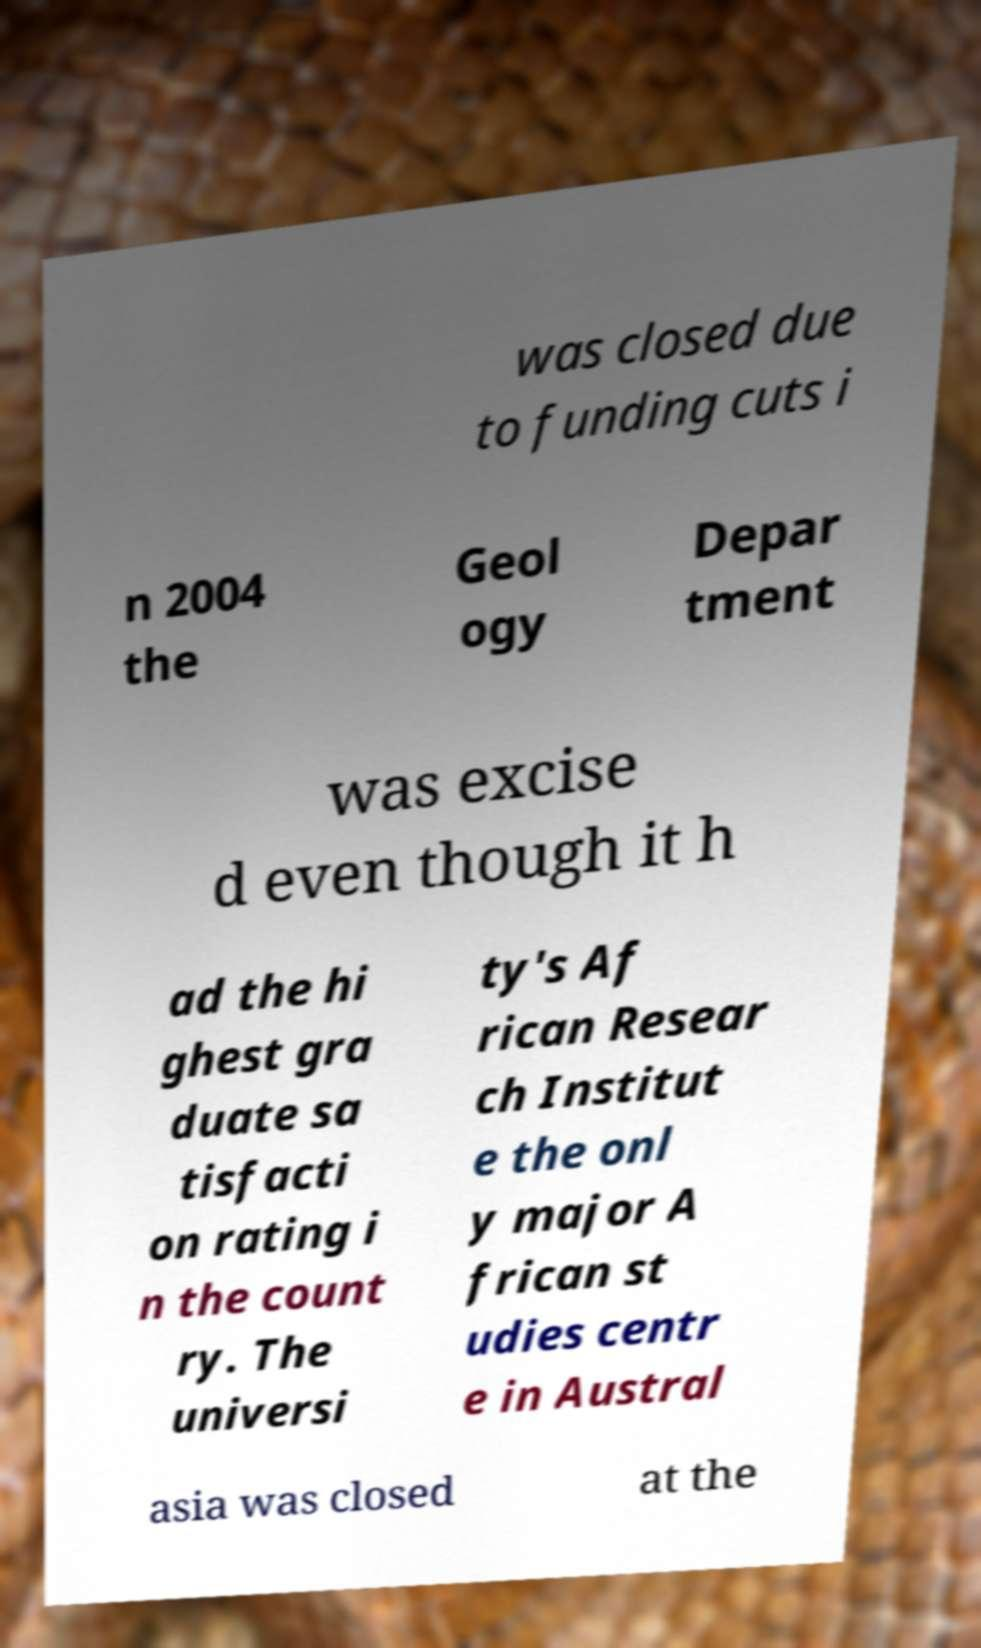What messages or text are displayed in this image? I need them in a readable, typed format. was closed due to funding cuts i n 2004 the Geol ogy Depar tment was excise d even though it h ad the hi ghest gra duate sa tisfacti on rating i n the count ry. The universi ty's Af rican Resear ch Institut e the onl y major A frican st udies centr e in Austral asia was closed at the 